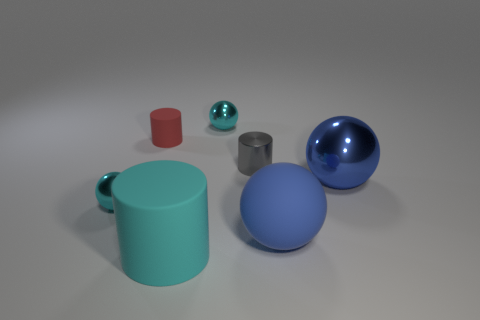Does the cyan cylinder have the same material as the cylinder behind the small gray shiny cylinder?
Ensure brevity in your answer.  Yes. Are there any matte balls of the same color as the big metal sphere?
Ensure brevity in your answer.  Yes. How many other objects are the same material as the tiny gray object?
Offer a terse response. 3. Is the color of the tiny shiny cylinder the same as the small metal ball that is behind the tiny red matte thing?
Offer a very short reply. No. Are there more matte spheres behind the cyan matte cylinder than gray cylinders?
Your answer should be compact. No. What number of tiny gray cylinders are in front of the small thing that is to the left of the red object that is behind the metal cylinder?
Your answer should be very brief. 0. There is a small cyan metallic object that is in front of the small matte cylinder; does it have the same shape as the small red rubber thing?
Ensure brevity in your answer.  No. There is a cyan sphere behind the large blue metallic object; what is it made of?
Offer a terse response. Metal. There is a small object that is both behind the gray object and to the right of the red object; what shape is it?
Offer a very short reply. Sphere. What is the material of the tiny red cylinder?
Your response must be concise. Rubber. 